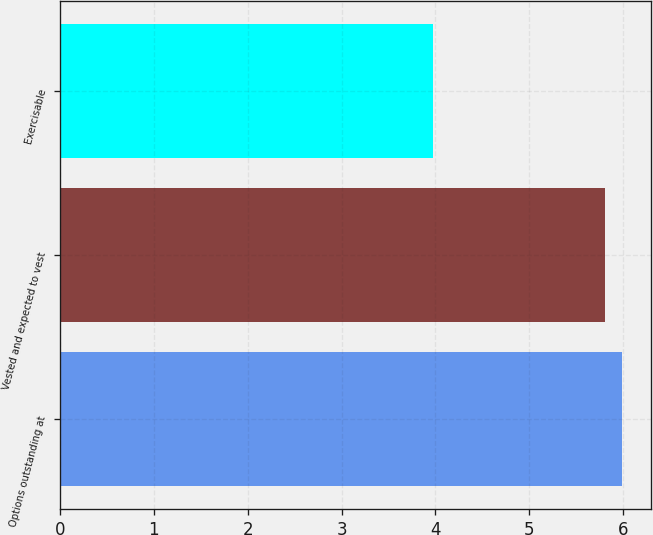<chart> <loc_0><loc_0><loc_500><loc_500><bar_chart><fcel>Options outstanding at<fcel>Vested and expected to vest<fcel>Exercisable<nl><fcel>5.99<fcel>5.8<fcel>3.97<nl></chart> 